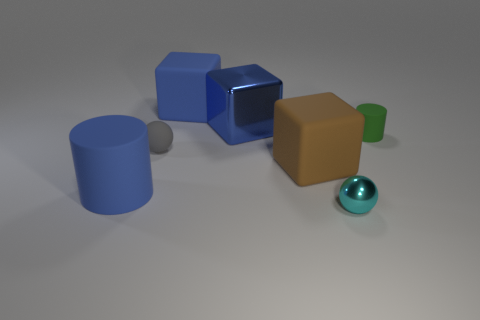There is a object that is in front of the large blue matte cylinder; does it have the same size as the cylinder behind the gray object?
Your answer should be very brief. Yes. There is another brown object that is the same shape as the big metal object; what is its material?
Keep it short and to the point. Rubber. How many big things are green cylinders or red cubes?
Your response must be concise. 0. What is the material of the big brown thing?
Provide a succinct answer. Rubber. There is a thing that is both in front of the green rubber object and on the right side of the large brown rubber cube; what material is it made of?
Offer a very short reply. Metal. Do the big matte cylinder and the rubber cylinder behind the tiny rubber sphere have the same color?
Provide a short and direct response. No. What material is the brown block that is the same size as the blue rubber cylinder?
Your answer should be very brief. Rubber. Is there a green cylinder that has the same material as the large brown object?
Offer a very short reply. Yes. How many blue matte cylinders are there?
Make the answer very short. 1. Do the big blue cylinder and the sphere that is behind the cyan ball have the same material?
Your answer should be very brief. Yes. 